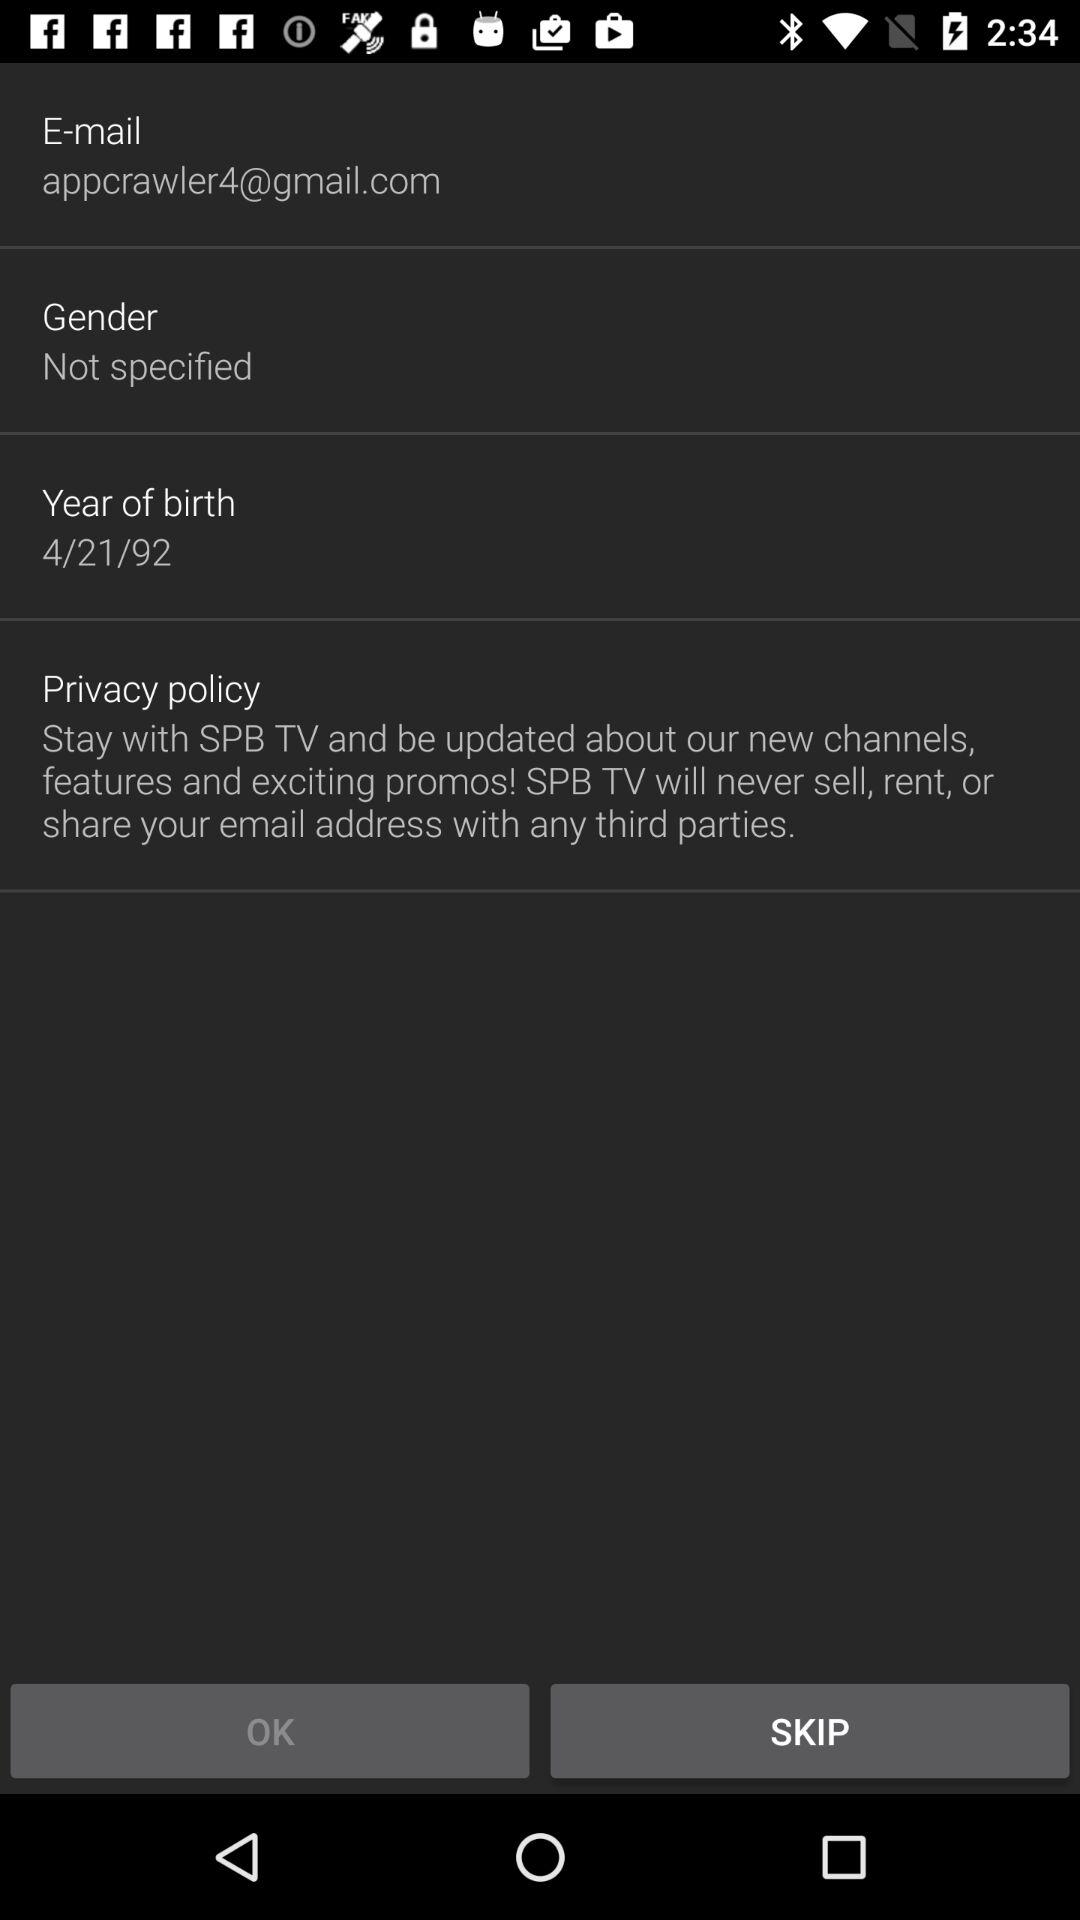How many fields are there in the form before the privacy policy?
Answer the question using a single word or phrase. 3 